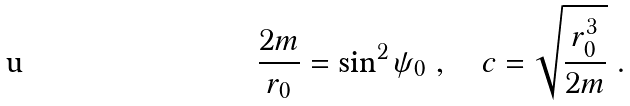Convert formula to latex. <formula><loc_0><loc_0><loc_500><loc_500>\frac { 2 m } { r _ { 0 } } = \sin ^ { 2 } \psi _ { 0 } \ , \quad c = \sqrt { \frac { r _ { 0 } ^ { 3 } } { 2 m } } \ .</formula> 